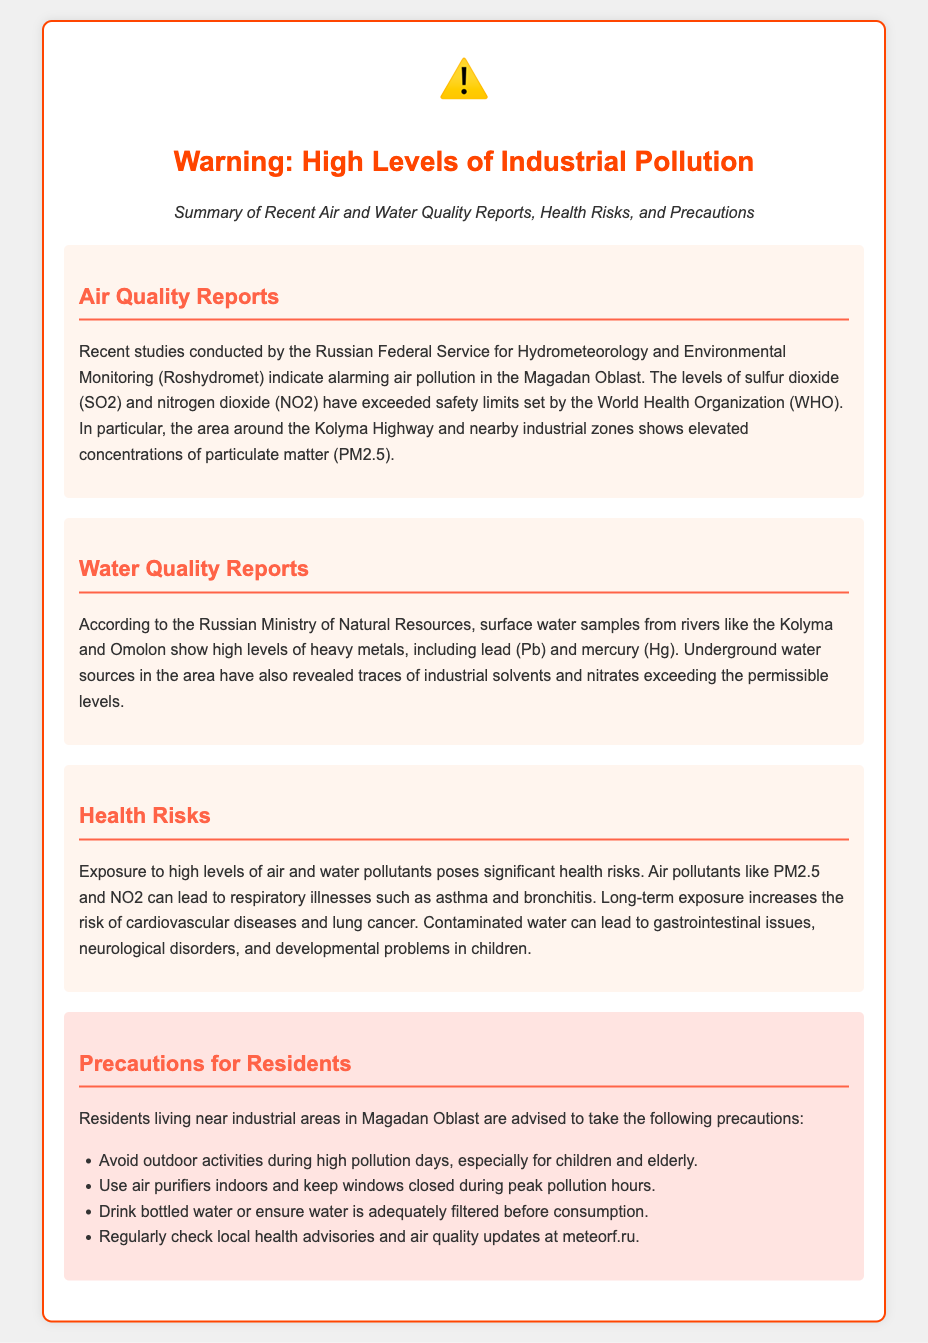What pollutants are mentioned in the air quality reports? The air quality reports mention sulfur dioxide and nitrogen dioxide as pollutants that have exceeded safety limits.
Answer: sulfur dioxide, nitrogen dioxide What heavy metals were found in the water quality reports? The water quality reports specify that lead and mercury were found in high levels in surface water samples.
Answer: lead, mercury What is the consequence of long-term exposure to air pollutants? The document states that long-term exposure increases the risk of cardiovascular diseases and lung cancer.
Answer: cardiovascular diseases, lung cancer Which river samples revealed high levels of heavy metals? The document mentions surface water samples from the Kolyma and Omolon rivers showing high levels of heavy metals.
Answer: Kolyma, Omolon What should residents do during high pollution days? The document advises residents to avoid outdoor activities during high pollution days, particularly for vulnerable groups.
Answer: avoid outdoor activities How often should residents check local health advisories? While the document does not specify a frequency, it implies residents should regularly check for updates.
Answer: regularly What is the purpose of this document? The purpose of the document is to warn residents about industrial pollution and its health risks.
Answer: to warn residents about industrial pollution What is advised to be used indoors to improve air quality? The document recommends the use of air purifiers indoors to help improve air quality.
Answer: air purifiers What type of health issues can contaminated water cause? Contaminated water can lead to gastrointestinal issues, neurological disorders, and developmental problems in children.
Answer: gastrointestinal issues, neurological disorders, developmental problems 